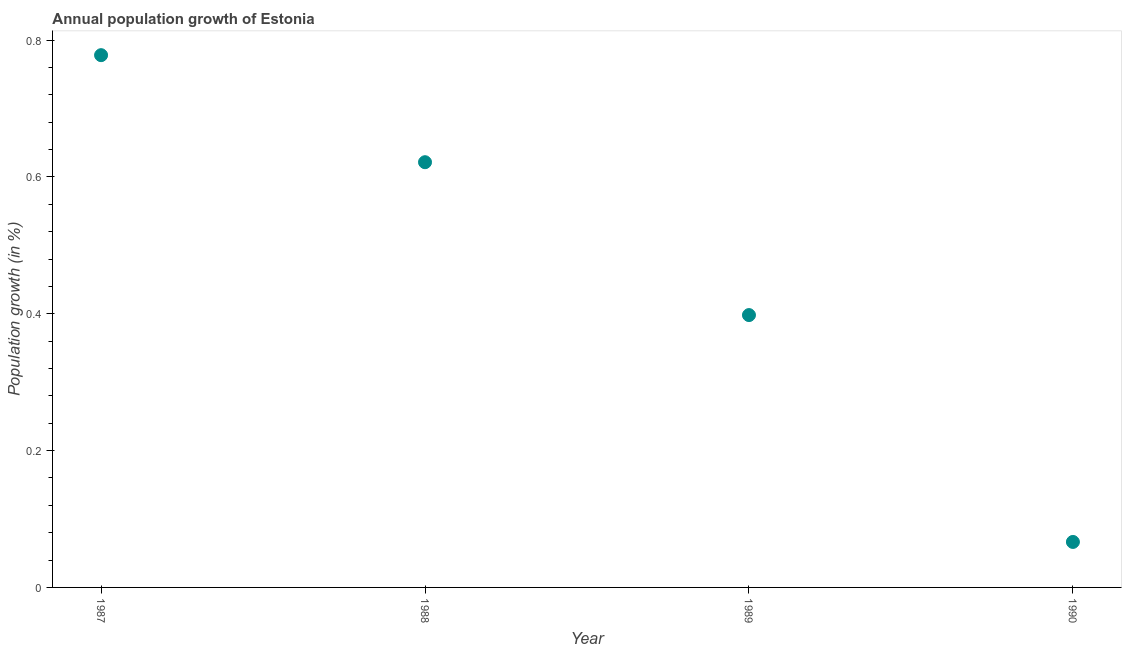What is the population growth in 1988?
Offer a terse response. 0.62. Across all years, what is the maximum population growth?
Offer a terse response. 0.78. Across all years, what is the minimum population growth?
Offer a terse response. 0.07. In which year was the population growth maximum?
Provide a short and direct response. 1987. In which year was the population growth minimum?
Your response must be concise. 1990. What is the sum of the population growth?
Your answer should be very brief. 1.86. What is the difference between the population growth in 1989 and 1990?
Keep it short and to the point. 0.33. What is the average population growth per year?
Your answer should be very brief. 0.47. What is the median population growth?
Give a very brief answer. 0.51. Do a majority of the years between 1987 and 1988 (inclusive) have population growth greater than 0.7600000000000001 %?
Make the answer very short. No. What is the ratio of the population growth in 1987 to that in 1989?
Ensure brevity in your answer.  1.95. Is the population growth in 1988 less than that in 1990?
Your answer should be very brief. No. What is the difference between the highest and the second highest population growth?
Offer a terse response. 0.16. Is the sum of the population growth in 1989 and 1990 greater than the maximum population growth across all years?
Make the answer very short. No. What is the difference between the highest and the lowest population growth?
Offer a very short reply. 0.71. How many years are there in the graph?
Give a very brief answer. 4. What is the difference between two consecutive major ticks on the Y-axis?
Provide a succinct answer. 0.2. Are the values on the major ticks of Y-axis written in scientific E-notation?
Ensure brevity in your answer.  No. Does the graph contain grids?
Your answer should be compact. No. What is the title of the graph?
Your response must be concise. Annual population growth of Estonia. What is the label or title of the Y-axis?
Give a very brief answer. Population growth (in %). What is the Population growth (in %) in 1987?
Your response must be concise. 0.78. What is the Population growth (in %) in 1988?
Keep it short and to the point. 0.62. What is the Population growth (in %) in 1989?
Your answer should be very brief. 0.4. What is the Population growth (in %) in 1990?
Ensure brevity in your answer.  0.07. What is the difference between the Population growth (in %) in 1987 and 1988?
Keep it short and to the point. 0.16. What is the difference between the Population growth (in %) in 1987 and 1989?
Make the answer very short. 0.38. What is the difference between the Population growth (in %) in 1987 and 1990?
Give a very brief answer. 0.71. What is the difference between the Population growth (in %) in 1988 and 1989?
Ensure brevity in your answer.  0.22. What is the difference between the Population growth (in %) in 1988 and 1990?
Your response must be concise. 0.56. What is the difference between the Population growth (in %) in 1989 and 1990?
Keep it short and to the point. 0.33. What is the ratio of the Population growth (in %) in 1987 to that in 1988?
Ensure brevity in your answer.  1.25. What is the ratio of the Population growth (in %) in 1987 to that in 1989?
Offer a very short reply. 1.95. What is the ratio of the Population growth (in %) in 1987 to that in 1990?
Offer a terse response. 11.7. What is the ratio of the Population growth (in %) in 1988 to that in 1989?
Make the answer very short. 1.56. What is the ratio of the Population growth (in %) in 1988 to that in 1990?
Your answer should be compact. 9.35. What is the ratio of the Population growth (in %) in 1989 to that in 1990?
Offer a very short reply. 5.99. 